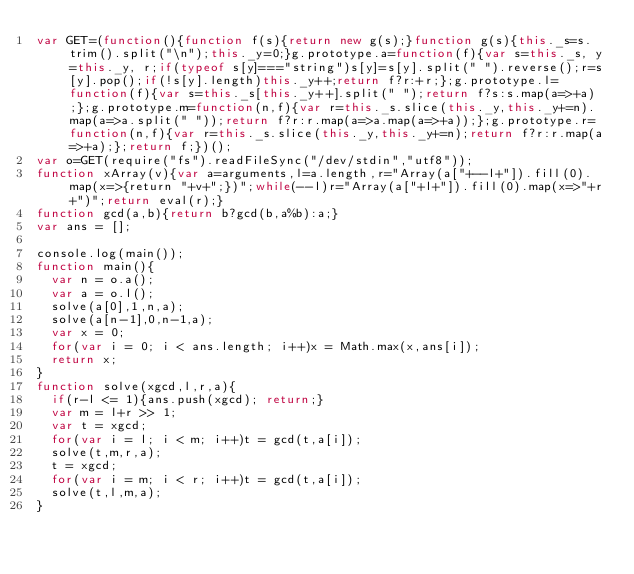<code> <loc_0><loc_0><loc_500><loc_500><_JavaScript_>var GET=(function(){function f(s){return new g(s);}function g(s){this._s=s.trim().split("\n");this._y=0;}g.prototype.a=function(f){var s=this._s, y=this._y, r;if(typeof s[y]==="string")s[y]=s[y].split(" ").reverse();r=s[y].pop();if(!s[y].length)this._y++;return f?r:+r;};g.prototype.l=function(f){var s=this._s[this._y++].split(" ");return f?s:s.map(a=>+a);};g.prototype.m=function(n,f){var r=this._s.slice(this._y,this._y+=n).map(a=>a.split(" "));return f?r:r.map(a=>a.map(a=>+a));};g.prototype.r=function(n,f){var r=this._s.slice(this._y,this._y+=n);return f?r:r.map(a=>+a);};return f;})();
var o=GET(require("fs").readFileSync("/dev/stdin","utf8"));
function xArray(v){var a=arguments,l=a.length,r="Array(a["+--l+"]).fill(0).map(x=>{return "+v+";})";while(--l)r="Array(a["+l+"]).fill(0).map(x=>"+r+")";return eval(r);}
function gcd(a,b){return b?gcd(b,a%b):a;}
var ans = [];

console.log(main());
function main(){
  var n = o.a();
  var a = o.l();
  solve(a[0],1,n,a);
  solve(a[n-1],0,n-1,a);
  var x = 0;
  for(var i = 0; i < ans.length; i++)x = Math.max(x,ans[i]);
  return x;
}
function solve(xgcd,l,r,a){
  if(r-l <= 1){ans.push(xgcd); return;}
  var m = l+r >> 1;
  var t = xgcd;
  for(var i = l; i < m; i++)t = gcd(t,a[i]);
  solve(t,m,r,a);
  t = xgcd;
  for(var i = m; i < r; i++)t = gcd(t,a[i]);
  solve(t,l,m,a);
}</code> 